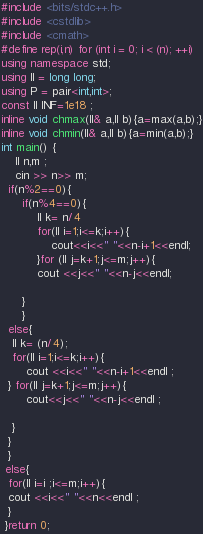<code> <loc_0><loc_0><loc_500><loc_500><_C++_>#include <bits/stdc++.h>
#include <cstdlib>
#include <cmath>
#define rep(i,n) for (int i = 0; i < (n); ++i)
using namespace std;
using ll = long long;
using P = pair<int,int>;
const ll INF=1e18 ;
inline void chmax(ll& a,ll b){a=max(a,b);}
inline void chmin(ll& a,ll b){a=min(a,b);}
int main() {
    ll n,m ;
    cin >> n>> m;
  if(n%2==0){
      if(n%4==0){
          ll k= n/4
          for(ll i=1;i<=k;i++){
              cout<<i<<" "<<n-i+1<<endl;
          }for (ll j=k+1;j<=m;j++){
          cout <<j<<" "<<n-j<<endl;
          
      }
      }
  else{
   ll k= (n/4);
   for(ll i=1;i<=k;i++){
       cout <<i<<" "<<n-i+1<<endl ;
  } for(ll j=k+1;j<=m;j++){
       cout<<j<<" "<<n-j<<endl ;
   
   }
  }
  }  
 else{
  for(ll i=i ;i<=m;i++){
  cout <<i<<" "<<n<<endl ; 
  } 
 }return 0;

</code> 